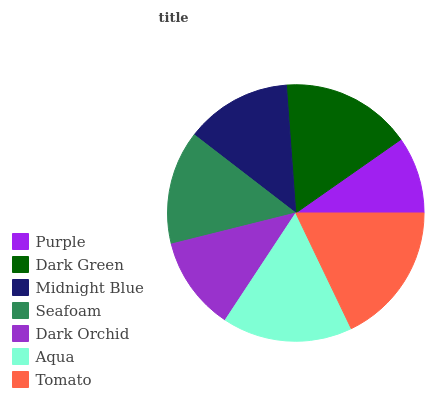Is Purple the minimum?
Answer yes or no. Yes. Is Tomato the maximum?
Answer yes or no. Yes. Is Dark Green the minimum?
Answer yes or no. No. Is Dark Green the maximum?
Answer yes or no. No. Is Dark Green greater than Purple?
Answer yes or no. Yes. Is Purple less than Dark Green?
Answer yes or no. Yes. Is Purple greater than Dark Green?
Answer yes or no. No. Is Dark Green less than Purple?
Answer yes or no. No. Is Seafoam the high median?
Answer yes or no. Yes. Is Seafoam the low median?
Answer yes or no. Yes. Is Tomato the high median?
Answer yes or no. No. Is Midnight Blue the low median?
Answer yes or no. No. 